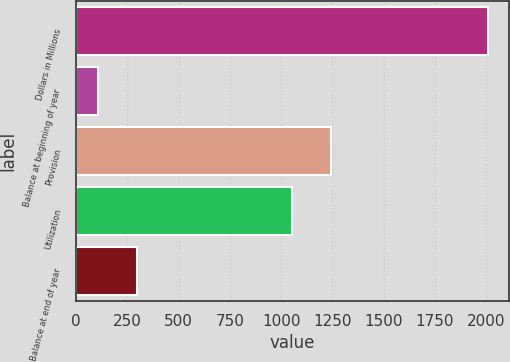<chart> <loc_0><loc_0><loc_500><loc_500><bar_chart><fcel>Dollars in Millions<fcel>Balance at beginning of year<fcel>Provision<fcel>Utilization<fcel>Balance at end of year<nl><fcel>2011<fcel>107<fcel>1244.4<fcel>1054<fcel>297.4<nl></chart> 